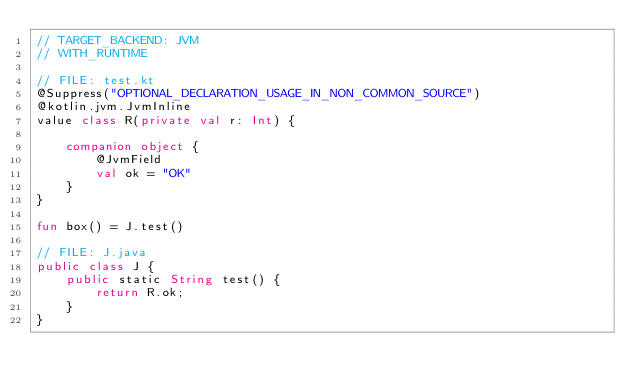Convert code to text. <code><loc_0><loc_0><loc_500><loc_500><_Kotlin_>// TARGET_BACKEND: JVM
// WITH_RUNTIME

// FILE: test.kt
@Suppress("OPTIONAL_DECLARATION_USAGE_IN_NON_COMMON_SOURCE")
@kotlin.jvm.JvmInline
value class R(private val r: Int) {

    companion object {
        @JvmField
        val ok = "OK"
    }
}

fun box() = J.test()

// FILE: J.java
public class J {
    public static String test() {
        return R.ok;
    }
}</code> 